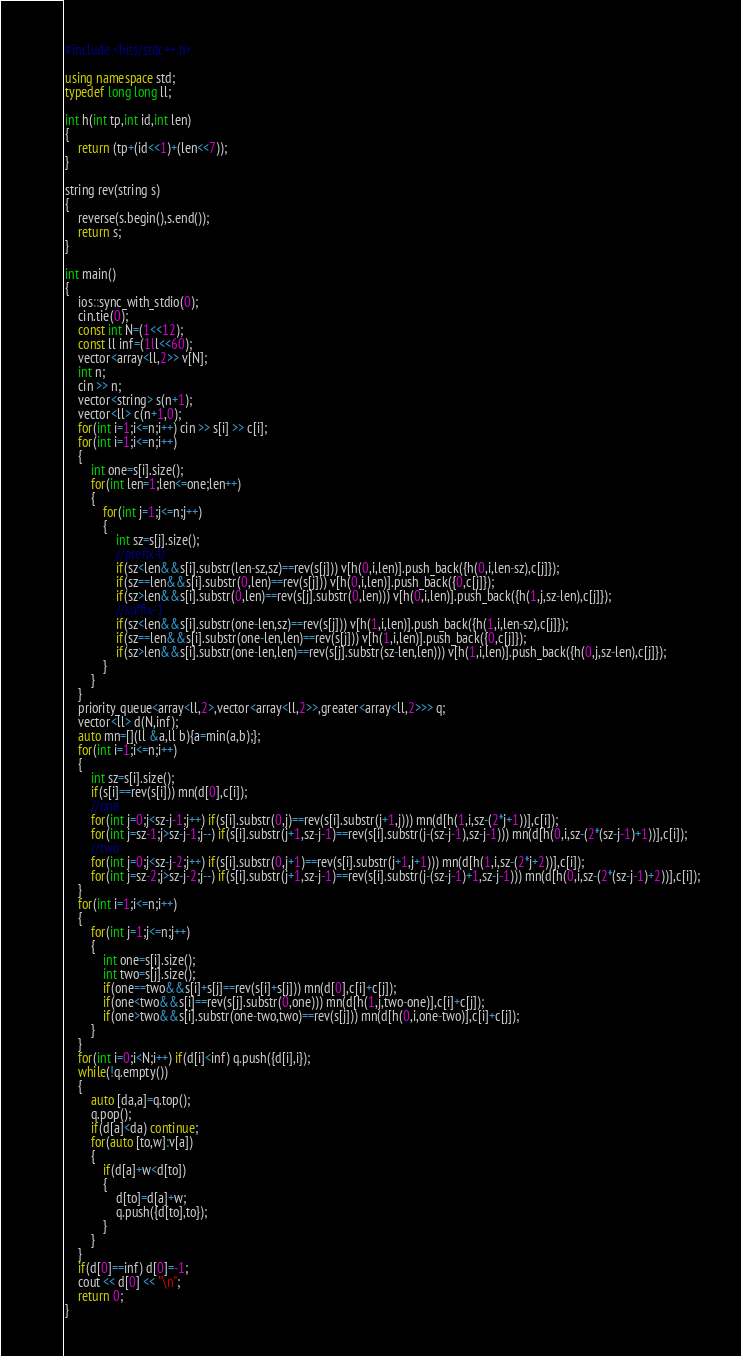Convert code to text. <code><loc_0><loc_0><loc_500><loc_500><_C++_>#include <bits/stdc++.h>

using namespace std;
typedef long long ll;

int h(int tp,int id,int len)
{
    return (tp+(id<<1)+(len<<7));
}

string rev(string s)
{
    reverse(s.begin(),s.end());
    return s;
}

int main()
{
    ios::sync_with_stdio(0);
    cin.tie(0);
    const int N=(1<<12);
    const ll inf=(1ll<<60);
    vector<array<ll,2>> v[N];
    int n;
    cin >> n;
    vector<string> s(n+1);
    vector<ll> c(n+1,0);
    for(int i=1;i<=n;i++) cin >> s[i] >> c[i];
    for(int i=1;i<=n;i++)
    {
        int one=s[i].size();
        for(int len=1;len<=one;len++)
        {
            for(int j=1;j<=n;j++)
            {
                int sz=s[j].size();
                //prefix-0
                if(sz<len&&s[i].substr(len-sz,sz)==rev(s[j])) v[h(0,i,len)].push_back({h(0,i,len-sz),c[j]});
                if(sz==len&&s[i].substr(0,len)==rev(s[j])) v[h(0,i,len)].push_back({0,c[j]});
                if(sz>len&&s[i].substr(0,len)==rev(s[j].substr(0,len))) v[h(0,i,len)].push_back({h(1,j,sz-len),c[j]});
                //suffix-1
                if(sz<len&&s[i].substr(one-len,sz)==rev(s[j])) v[h(1,i,len)].push_back({h(1,i,len-sz),c[j]});
                if(sz==len&&s[i].substr(one-len,len)==rev(s[j])) v[h(1,i,len)].push_back({0,c[j]});
                if(sz>len&&s[i].substr(one-len,len)==rev(s[j].substr(sz-len,len))) v[h(1,i,len)].push_back({h(0,j,sz-len),c[j]});
            }
        }
    }
    priority_queue<array<ll,2>,vector<array<ll,2>>,greater<array<ll,2>>> q;
    vector<ll> d(N,inf);
    auto mn=[](ll &a,ll b){a=min(a,b);};
    for(int i=1;i<=n;i++)
    {
        int sz=s[i].size();
        if(s[i]==rev(s[i])) mn(d[0],c[i]);
        //one
        for(int j=0;j<sz-j-1;j++) if(s[i].substr(0,j)==rev(s[i].substr(j+1,j))) mn(d[h(1,i,sz-(2*j+1))],c[i]);
        for(int j=sz-1;j>sz-j-1;j--) if(s[i].substr(j+1,sz-j-1)==rev(s[i].substr(j-(sz-j-1),sz-j-1))) mn(d[h(0,i,sz-(2*(sz-j-1)+1))],c[i]);
        //two
        for(int j=0;j<sz-j-2;j++) if(s[i].substr(0,j+1)==rev(s[i].substr(j+1,j+1))) mn(d[h(1,i,sz-(2*j+2))],c[i]);
        for(int j=sz-2;j>sz-j-2;j--) if(s[i].substr(j+1,sz-j-1)==rev(s[i].substr(j-(sz-j-1)+1,sz-j-1))) mn(d[h(0,i,sz-(2*(sz-j-1)+2))],c[i]);
    }
    for(int i=1;i<=n;i++)
    {
        for(int j=1;j<=n;j++)
        {
            int one=s[i].size();
            int two=s[j].size();
            if(one==two&&s[i]+s[j]==rev(s[i]+s[j])) mn(d[0],c[i]+c[j]);
            if(one<two&&s[i]==rev(s[j].substr(0,one))) mn(d[h(1,j,two-one)],c[i]+c[j]);
            if(one>two&&s[i].substr(one-two,two)==rev(s[j])) mn(d[h(0,i,one-two)],c[i]+c[j]);
        }
    }
    for(int i=0;i<N;i++) if(d[i]<inf) q.push({d[i],i});
    while(!q.empty())
    {
        auto [da,a]=q.top();
        q.pop();
        if(d[a]<da) continue;
        for(auto [to,w]:v[a])
        {
            if(d[a]+w<d[to])
            {
                d[to]=d[a]+w;
                q.push({d[to],to});
            }
        }
    }
    if(d[0]==inf) d[0]=-1;
    cout << d[0] << "\n";
    return 0;
}
</code> 